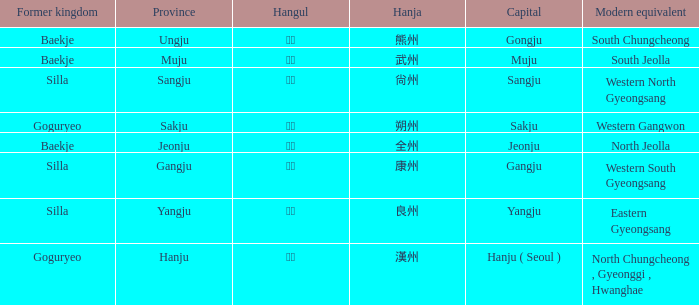What is the hangul symbol for the hanja 良州? 양주. 